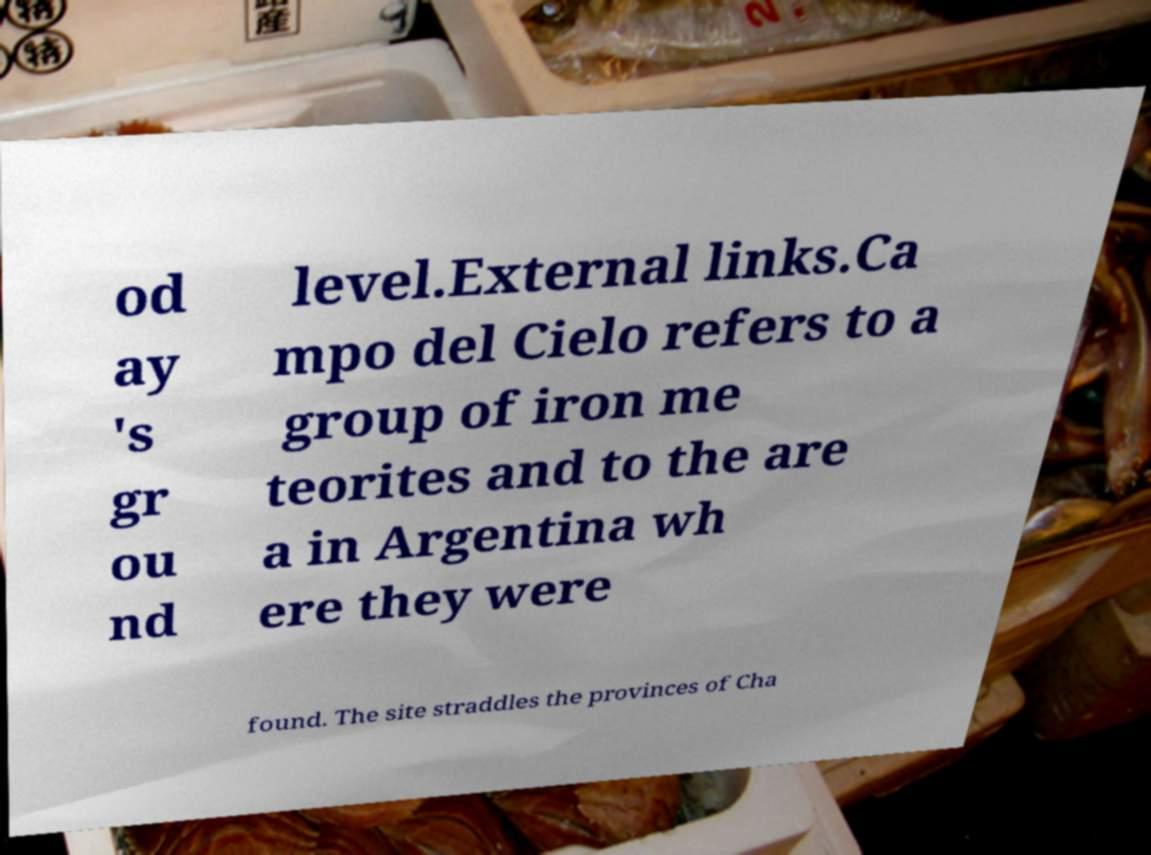Can you read and provide the text displayed in the image?This photo seems to have some interesting text. Can you extract and type it out for me? od ay 's gr ou nd level.External links.Ca mpo del Cielo refers to a group of iron me teorites and to the are a in Argentina wh ere they were found. The site straddles the provinces of Cha 